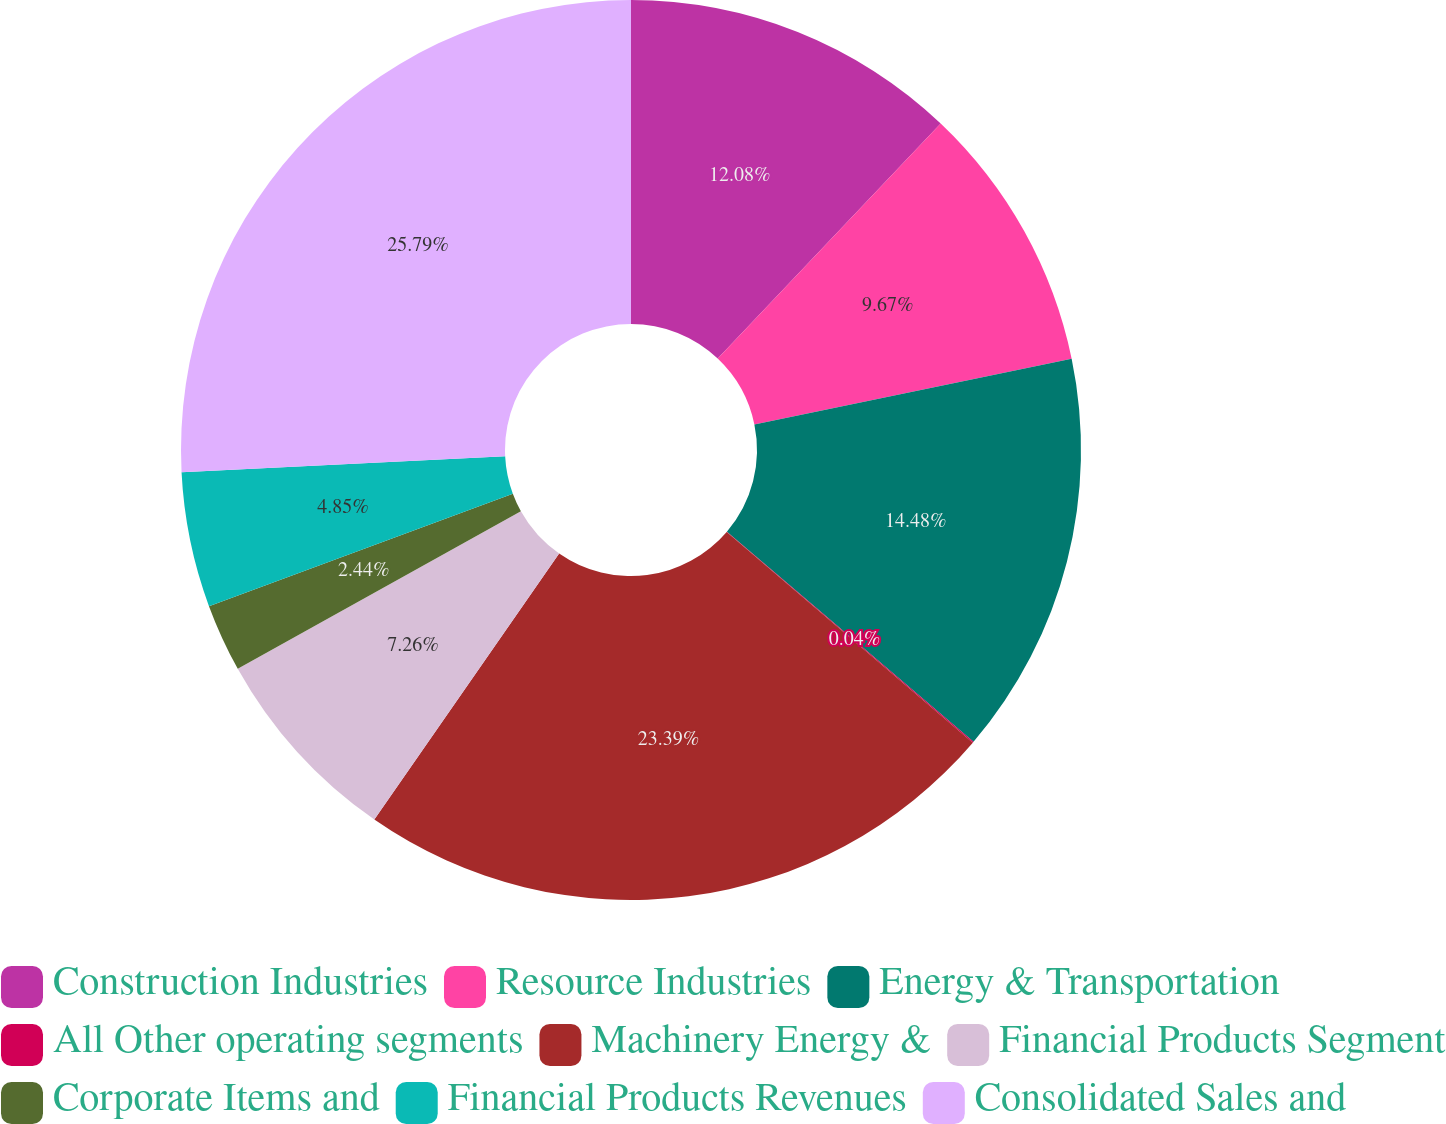Convert chart to OTSL. <chart><loc_0><loc_0><loc_500><loc_500><pie_chart><fcel>Construction Industries<fcel>Resource Industries<fcel>Energy & Transportation<fcel>All Other operating segments<fcel>Machinery Energy &<fcel>Financial Products Segment<fcel>Corporate Items and<fcel>Financial Products Revenues<fcel>Consolidated Sales and<nl><fcel>12.08%<fcel>9.67%<fcel>14.48%<fcel>0.04%<fcel>23.39%<fcel>7.26%<fcel>2.44%<fcel>4.85%<fcel>25.79%<nl></chart> 